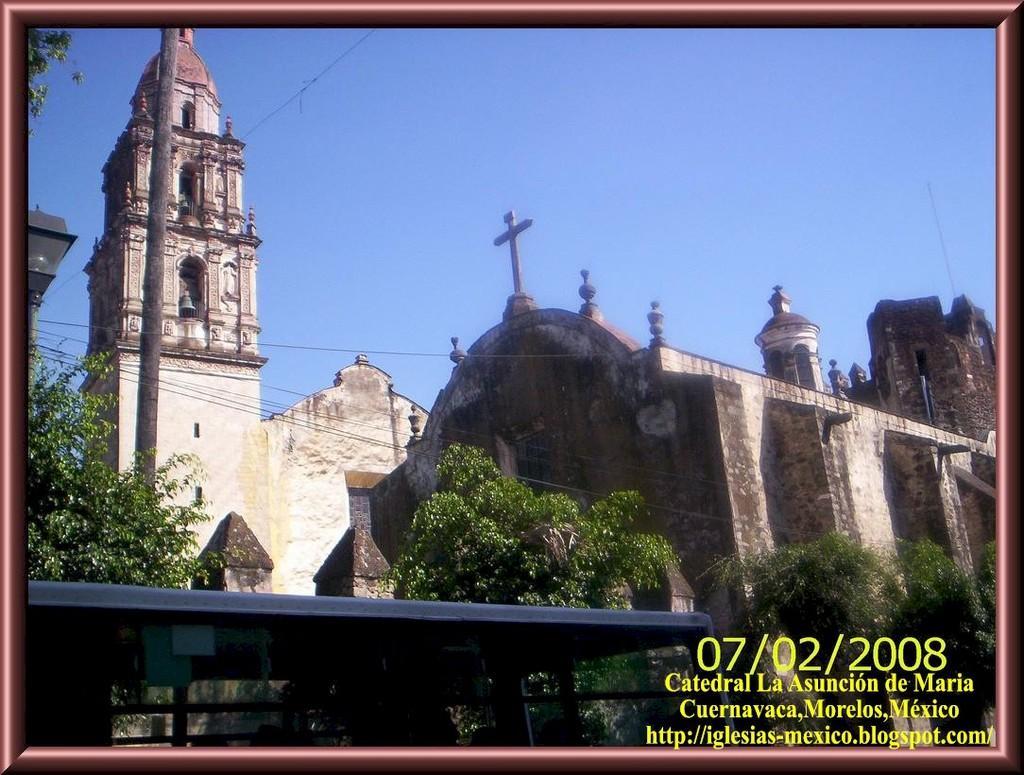Please provide a concise description of this image. In this image we can see some buildings with the cross and a bell. We can also see a pole, wires, trees, a roof with some metal poles and the sky which looks cloudy. On the bottom of the image we can see some text. 